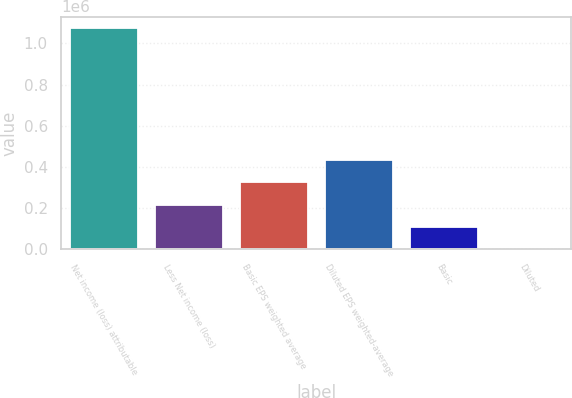Convert chart. <chart><loc_0><loc_0><loc_500><loc_500><bar_chart><fcel>Net income (loss) attributable<fcel>Less Net income (loss)<fcel>Basic EPS weighted average<fcel>Diluted EPS weighted-average<fcel>Basic<fcel>Diluted<nl><fcel>1.07599e+06<fcel>217184<fcel>325771<fcel>434359<fcel>108596<fcel>7.96<nl></chart> 